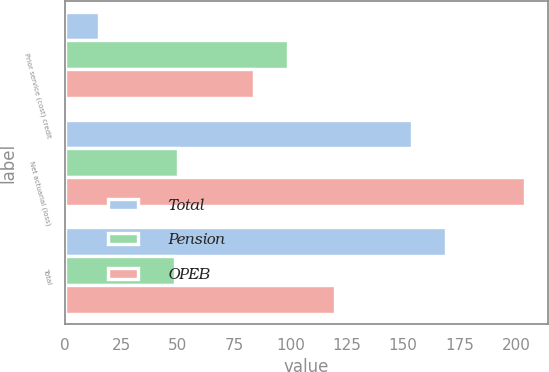Convert chart to OTSL. <chart><loc_0><loc_0><loc_500><loc_500><stacked_bar_chart><ecel><fcel>Prior service (cost) credit<fcel>Net actuarial (loss)<fcel>Total<nl><fcel>Total<fcel>15<fcel>154<fcel>169<nl><fcel>Pension<fcel>99<fcel>50<fcel>49<nl><fcel>OPEB<fcel>84<fcel>204<fcel>120<nl></chart> 